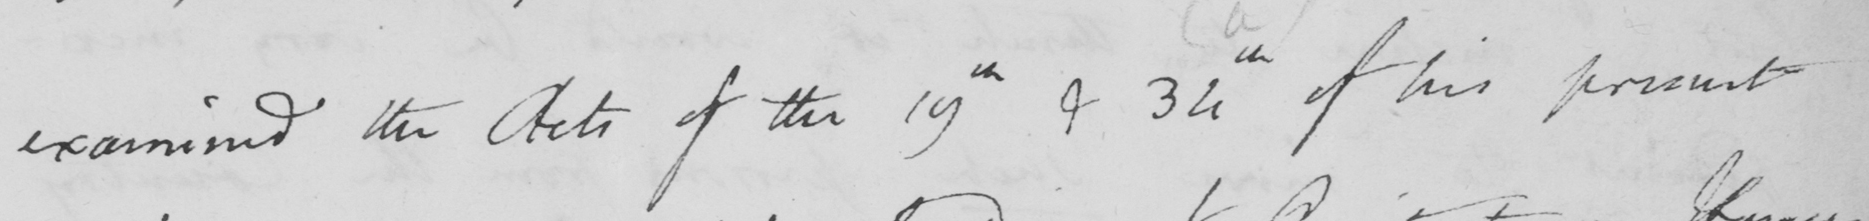What does this handwritten line say? examined the Acts of the 19th & 34th of his present 